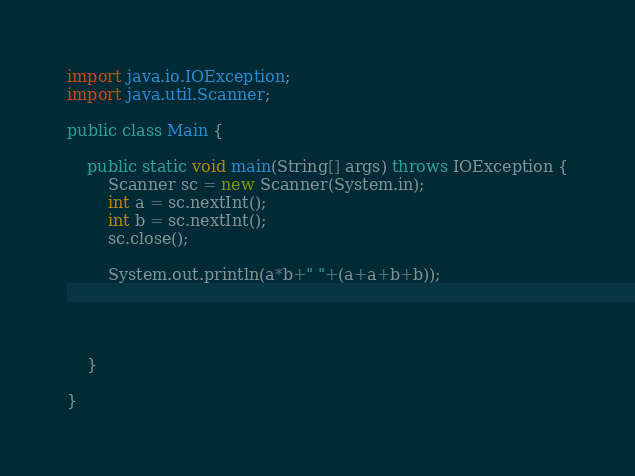<code> <loc_0><loc_0><loc_500><loc_500><_Java_>

import java.io.IOException;
import java.util.Scanner;

public class Main {

	public static void main(String[] args) throws IOException {
		Scanner sc = new Scanner(System.in);
		int a = sc.nextInt();
		int b = sc.nextInt();
		sc.close();

		System.out.println(a*b+" "+(a+a+b+b));




	}

}

</code> 